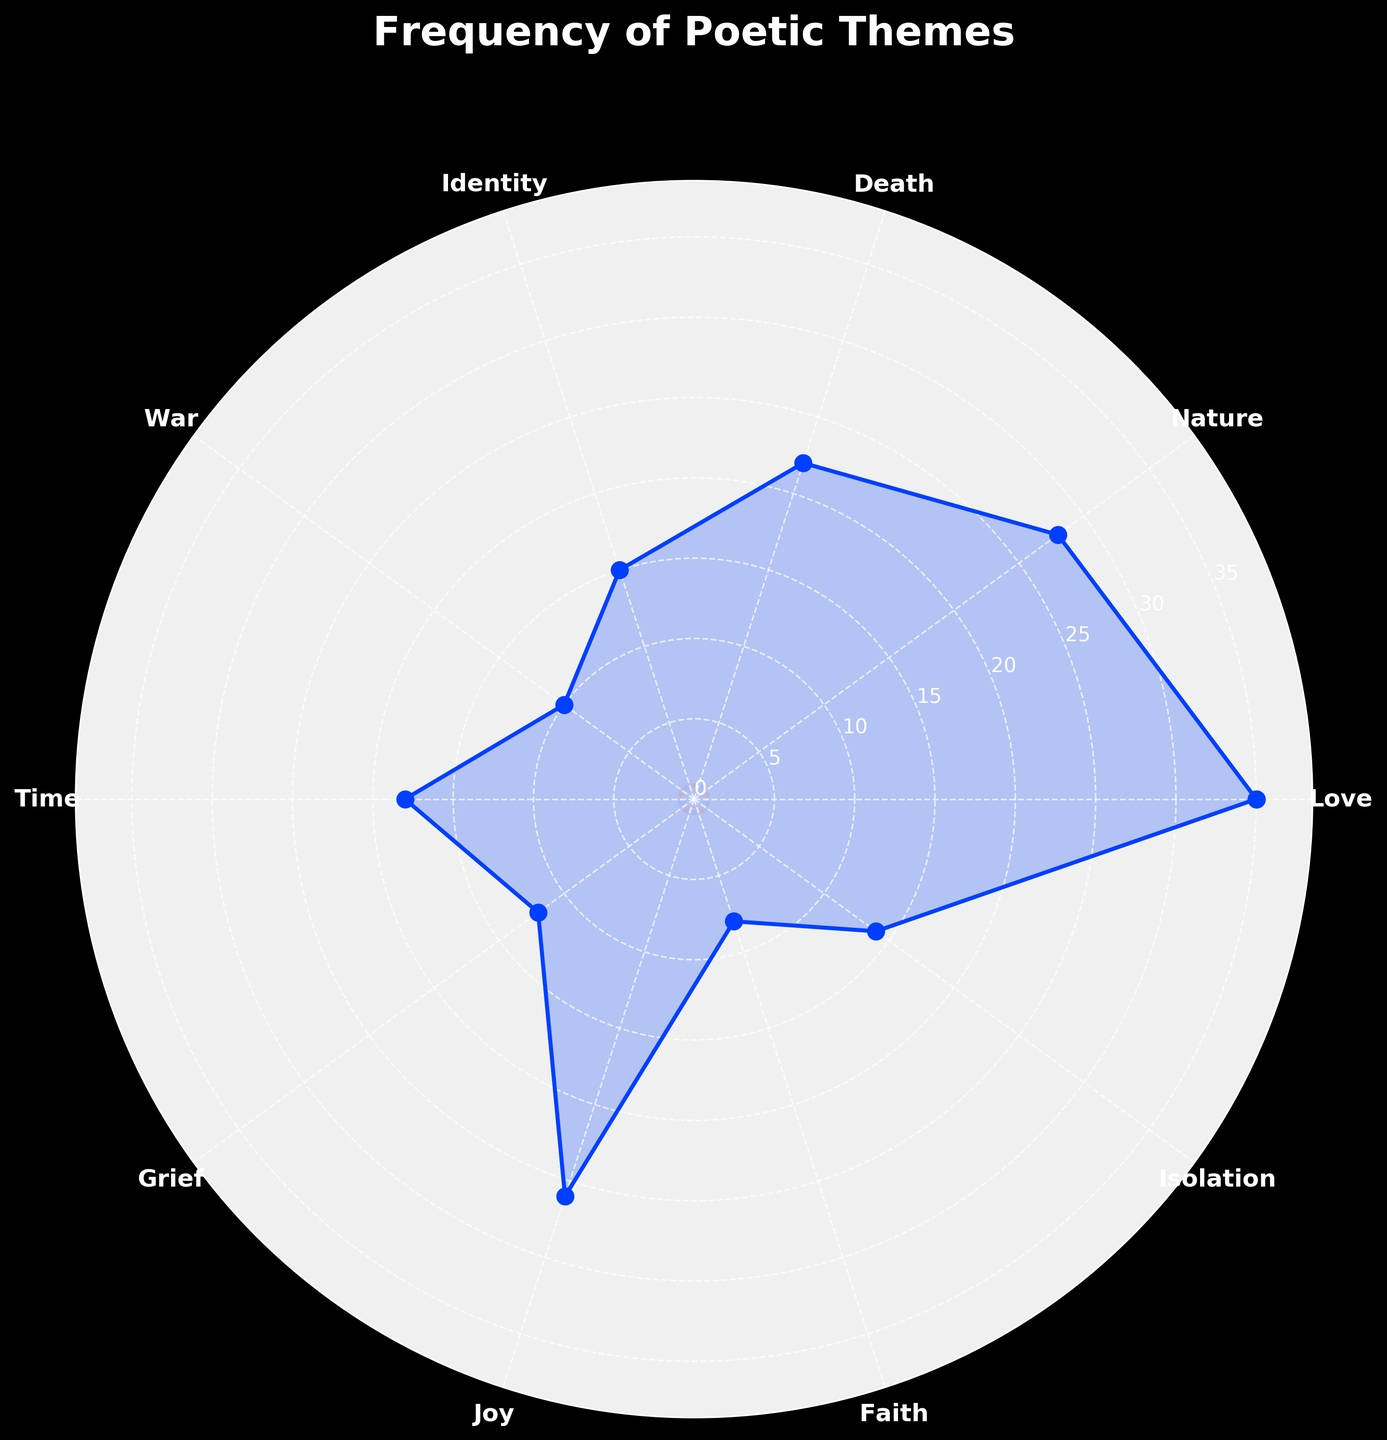What's the most frequently occurring theme? To determine the most frequent theme, look at the radial value for each theme and identify the one with the highest value, which is closest to the outer edge of the chart. The "Love" theme has the highest radial value.
Answer: Love Which theme has the lowest frequency? The theme with the lowest frequency is the one with the smallest radial value, nearest the center of the chart. This is "Faith."
Answer: Faith How many themes have a frequency greater than 20? To answer this, count the themes whose radial values exceed the marked radial value of 20. The themes "Love," "Nature," "Death," "Joy," and "Time" exceed this value.
Answer: 5 What is the sum of the frequencies for the themes 'Grief' and 'Isolation'? Add the frequencies for "Grief" (12) and "Isolation" (14). The sum is 12 + 14.
Answer: 26 Which theme is more frequent: 'War' or 'Faith'? Compare the radial values of "War" and "Faith". "War" has a radial value of 10 and "Faith" has a value of 8. Therefore, "War" is more frequent.
Answer: War What's the difference in frequency between the theme 'Love' and 'Death'? Subtract the frequency of "Death" (22) from the frequency of "Love" (35). The difference is 35 - 22.
Answer: 13 Which themes have frequencies between 10 and 20 inclusive? Identify themes whose radial values fall within the range (10, 20). These themes are "War," "Time," "Grief," "Isolation," and "Identity".
Answer: War, Time, Grief, Isolation, Identity What is the least frequent theme among 'Joy,' 'Grief,' and 'Isolation'? Compare the frequencies of "Joy" (26), "Grief" (12), and "Isolation" (14). "Grief" has the lowest frequency among the three.
Answer: Grief What is the angular position for the theme 'Nature'? Identify the position around the circle where "Nature" is labeled and note the corresponding angle. This is typically calculated by evenly spacing the themes along the circle. "Nature" is the second theme clockwise from the top.
Answer: 0.7π What is the average frequency of 'Time,' 'Grief,' and 'Faith'? Add the frequencies of "Time" (18), "Grief" (12), and "Faith" (8), then divide by the number of themes (3). The sum is 18 + 12 + 8 = 38, and the average is 38/3.
Answer: ~12.7 